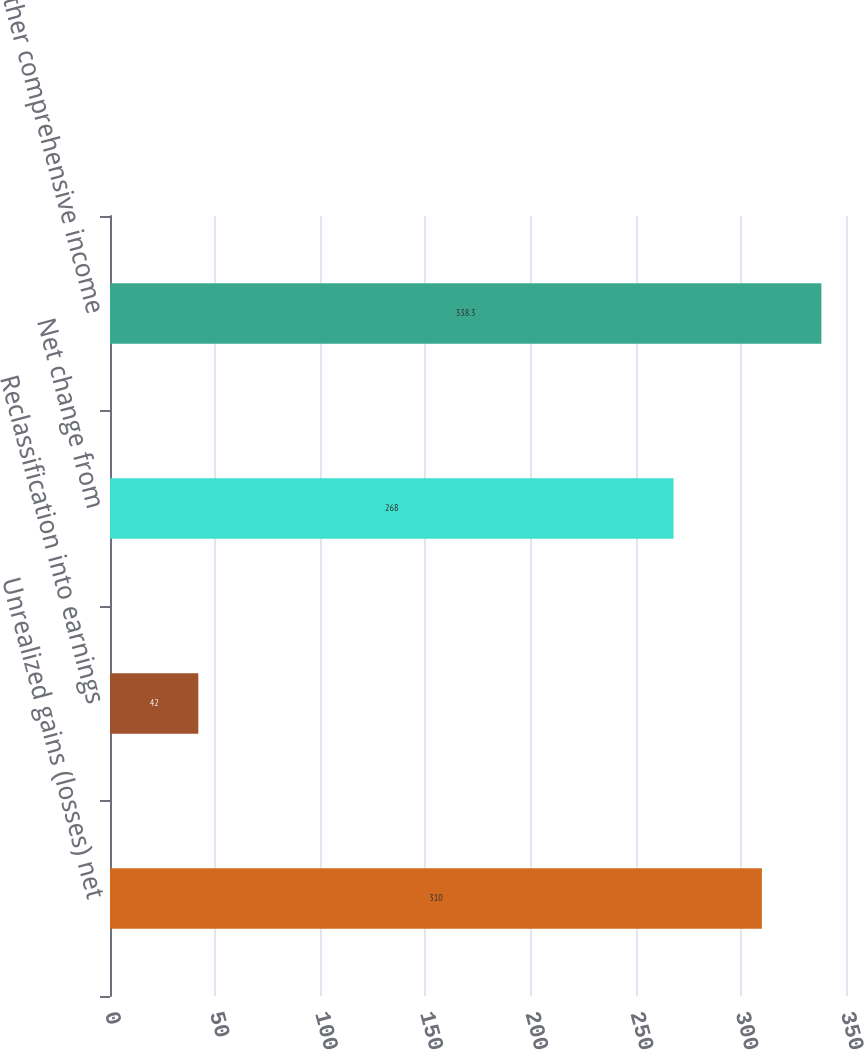Convert chart. <chart><loc_0><loc_0><loc_500><loc_500><bar_chart><fcel>Unrealized gains (losses) net<fcel>Reclassification into earnings<fcel>Net change from<fcel>Other comprehensive income<nl><fcel>310<fcel>42<fcel>268<fcel>338.3<nl></chart> 